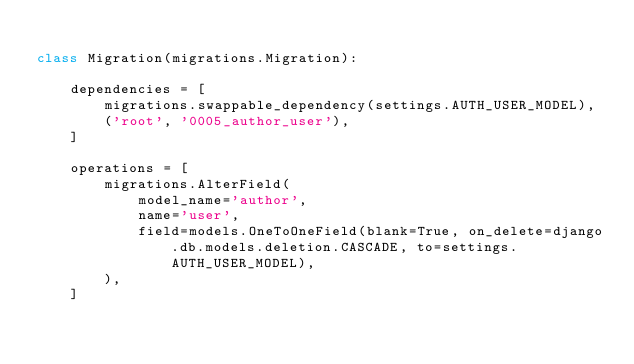Convert code to text. <code><loc_0><loc_0><loc_500><loc_500><_Python_>
class Migration(migrations.Migration):

    dependencies = [
        migrations.swappable_dependency(settings.AUTH_USER_MODEL),
        ('root', '0005_author_user'),
    ]

    operations = [
        migrations.AlterField(
            model_name='author',
            name='user',
            field=models.OneToOneField(blank=True, on_delete=django.db.models.deletion.CASCADE, to=settings.AUTH_USER_MODEL),
        ),
    ]
</code> 